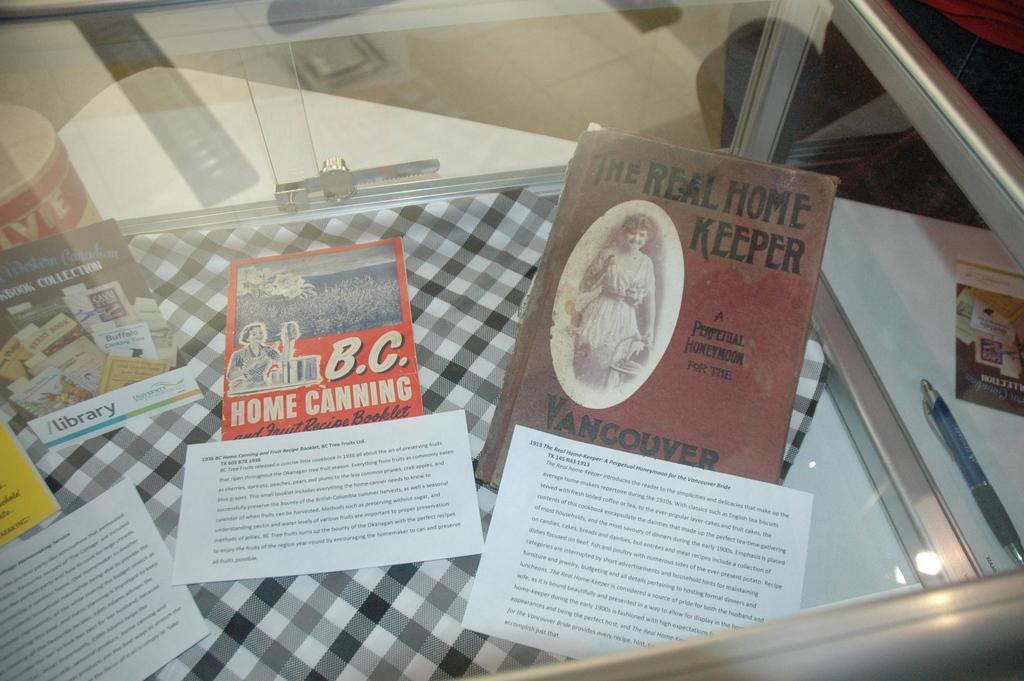<image>
Share a concise interpretation of the image provided. Several old books at house keeping are displayed in a case. 